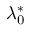Convert formula to latex. <formula><loc_0><loc_0><loc_500><loc_500>\lambda _ { 0 } ^ { \ast }</formula> 